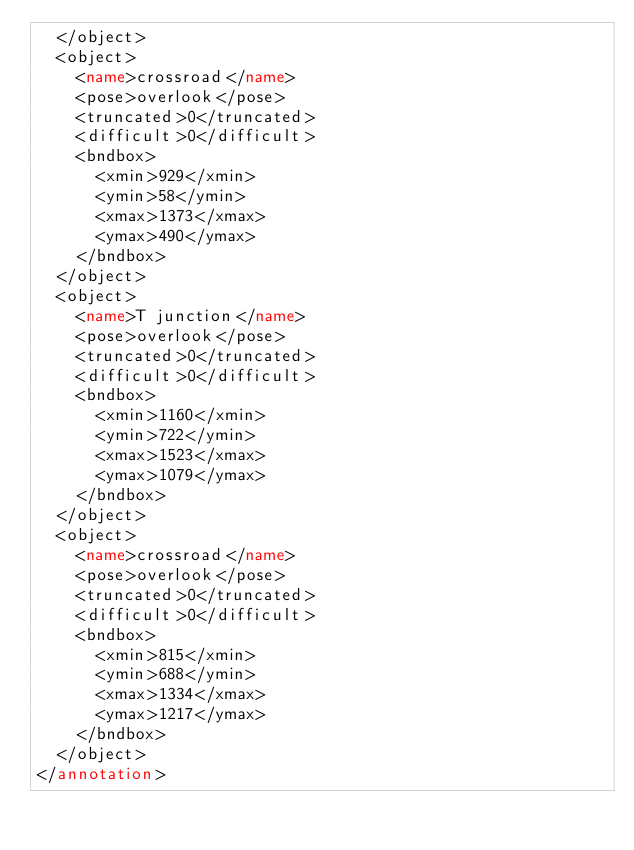Convert code to text. <code><loc_0><loc_0><loc_500><loc_500><_XML_>	</object>
	<object>
		<name>crossroad</name>
		<pose>overlook</pose>
		<truncated>0</truncated>
		<difficult>0</difficult>
		<bndbox>
			<xmin>929</xmin>
			<ymin>58</ymin>
			<xmax>1373</xmax>
			<ymax>490</ymax>
		</bndbox>
	</object>
	<object>
		<name>T junction</name>
		<pose>overlook</pose>
		<truncated>0</truncated>
		<difficult>0</difficult>
		<bndbox>
			<xmin>1160</xmin>
			<ymin>722</ymin>
			<xmax>1523</xmax>
			<ymax>1079</ymax>
		</bndbox>
	</object>
	<object>
		<name>crossroad</name>
		<pose>overlook</pose>
		<truncated>0</truncated>
		<difficult>0</difficult>
		<bndbox>
			<xmin>815</xmin>
			<ymin>688</ymin>
			<xmax>1334</xmax>
			<ymax>1217</ymax>
		</bndbox>
	</object>
</annotation>
</code> 